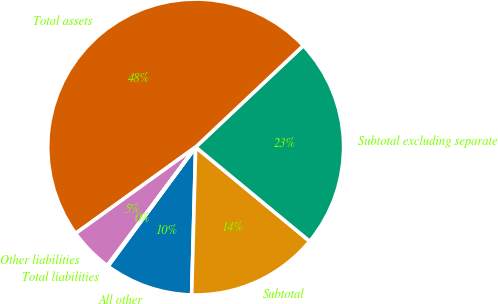<chart> <loc_0><loc_0><loc_500><loc_500><pie_chart><fcel>All other<fcel>Subtotal<fcel>Subtotal excluding separate<fcel>Total assets<fcel>Other liabilities<fcel>Total liabilities<nl><fcel>9.66%<fcel>14.44%<fcel>23.02%<fcel>47.9%<fcel>4.88%<fcel>0.1%<nl></chart> 